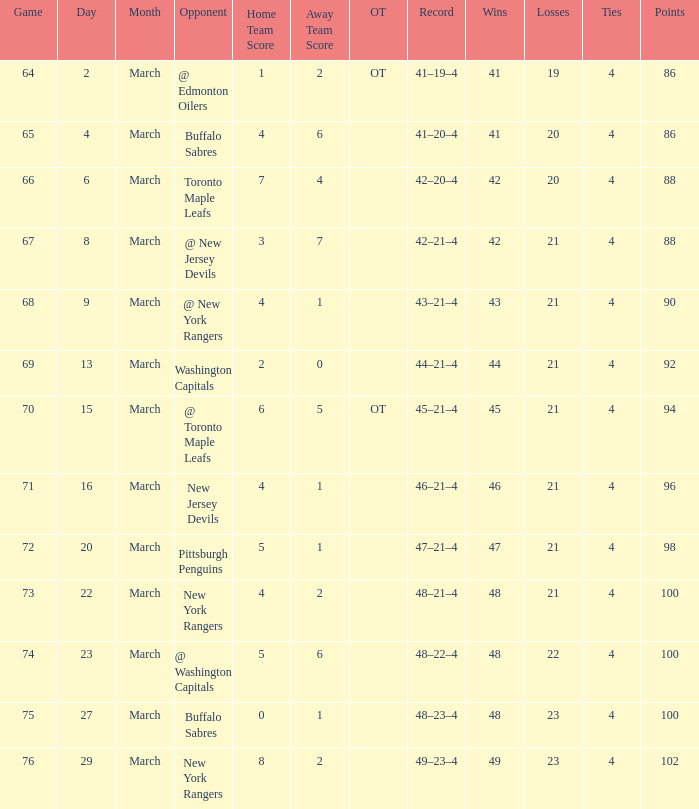Which points hold a record of 45-21-4, and a game greater than 70? None. 